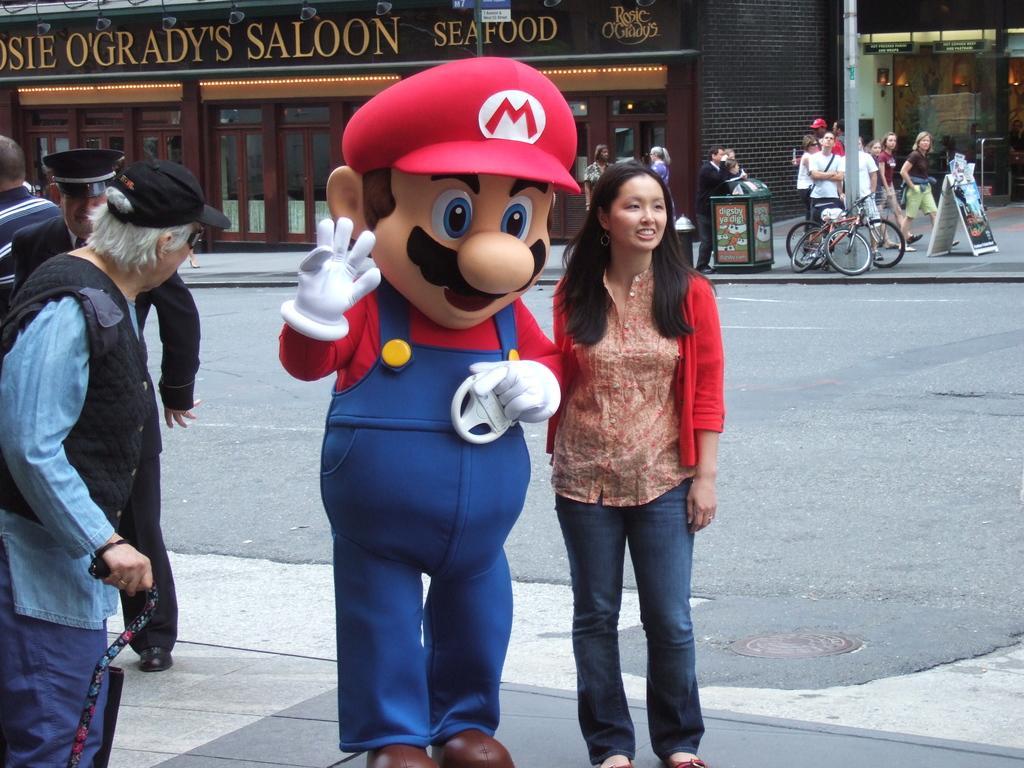Please provide a concise description of this image. In this image we can see a few people, there are bicycles, poles, boards with some text on it, there is a man holding a cane, there are houses, windows, a person is wearing a different costume, there are lights. 